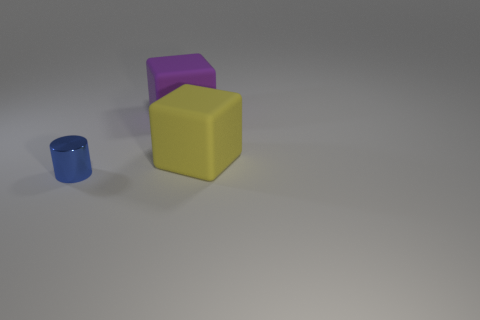The object that is both in front of the purple cube and to the right of the cylinder is made of what material?
Offer a terse response. Rubber. What color is the thing to the left of the matte block that is on the left side of the block that is right of the purple matte object?
Offer a terse response. Blue. The rubber cube that is the same size as the yellow object is what color?
Your answer should be compact. Purple. Does the tiny shiny cylinder have the same color as the large rubber cube behind the large yellow thing?
Offer a very short reply. No. What material is the big object that is on the right side of the big thing left of the yellow rubber block?
Give a very brief answer. Rubber. What number of objects are on the left side of the yellow matte thing and to the right of the metal cylinder?
Keep it short and to the point. 1. What number of other things are there of the same size as the purple object?
Provide a short and direct response. 1. There is a object that is in front of the yellow block; is its shape the same as the matte object behind the yellow matte object?
Your response must be concise. No. Are there any purple matte objects in front of the metallic cylinder?
Your answer should be compact. No. What color is the other matte thing that is the same shape as the large yellow object?
Your answer should be compact. Purple. 